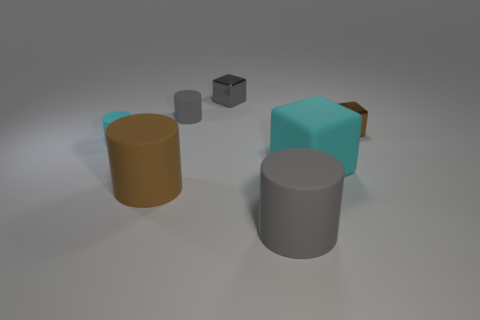Subtract all cyan cylinders. How many cylinders are left? 3 Add 1 yellow rubber balls. How many objects exist? 8 Subtract all cubes. How many objects are left? 4 Add 4 tiny gray objects. How many tiny gray objects are left? 6 Add 4 tiny gray shiny objects. How many tiny gray shiny objects exist? 5 Subtract 0 red spheres. How many objects are left? 7 Subtract all big green shiny blocks. Subtract all tiny gray objects. How many objects are left? 5 